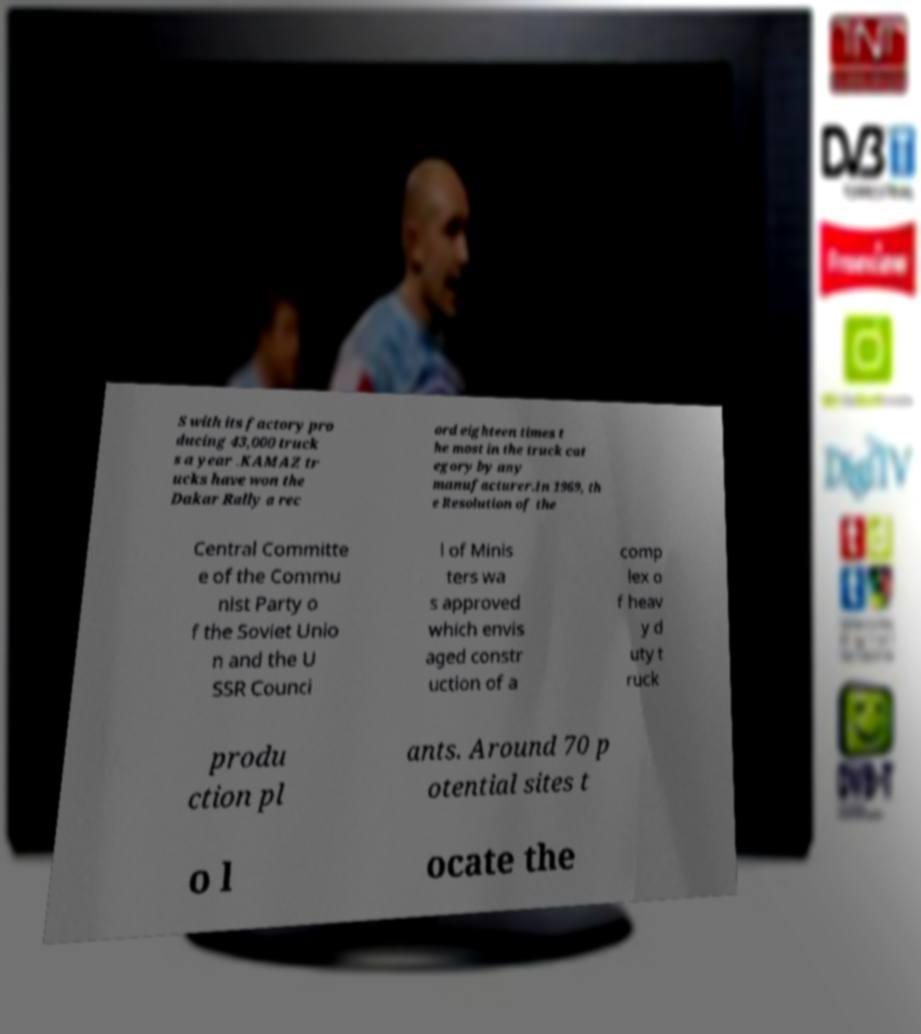There's text embedded in this image that I need extracted. Can you transcribe it verbatim? S with its factory pro ducing 43,000 truck s a year .KAMAZ tr ucks have won the Dakar Rally a rec ord eighteen times t he most in the truck cat egory by any manufacturer.In 1969, th e Resolution of the Central Committe e of the Commu nist Party o f the Soviet Unio n and the U SSR Counci l of Minis ters wa s approved which envis aged constr uction of a comp lex o f heav y d uty t ruck produ ction pl ants. Around 70 p otential sites t o l ocate the 